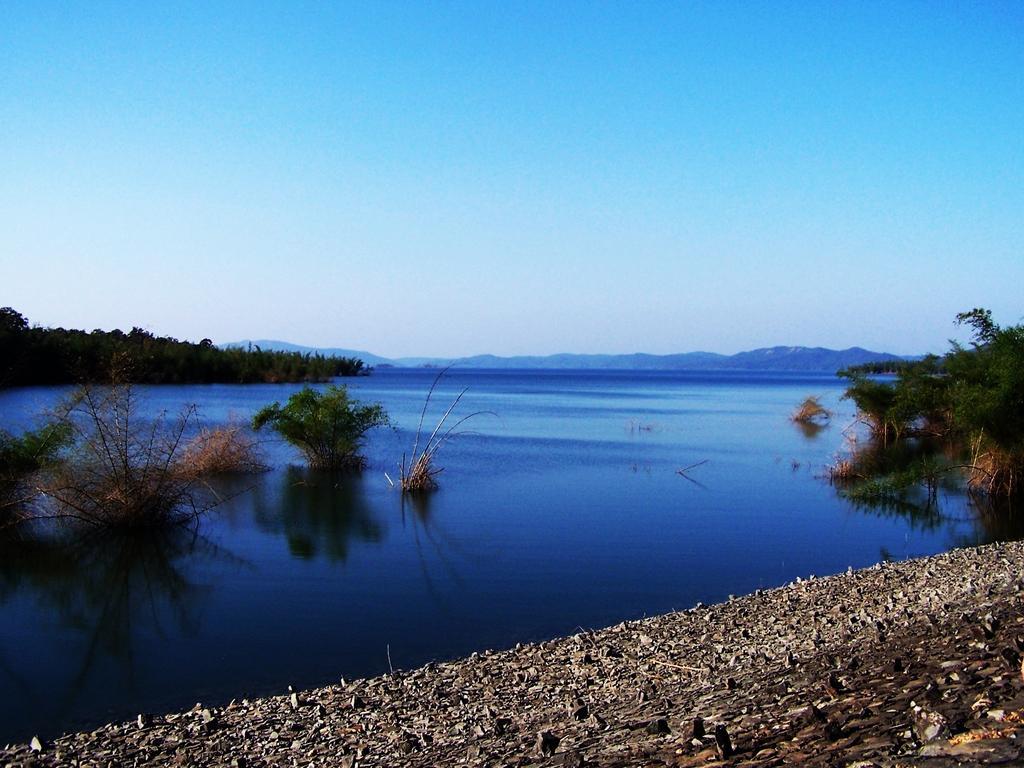Can you describe this image briefly? In this image we can see the water and there are some plants and trees and there are some stones on the ground. We can see the mountains in the background and at the top we can see the sky. 